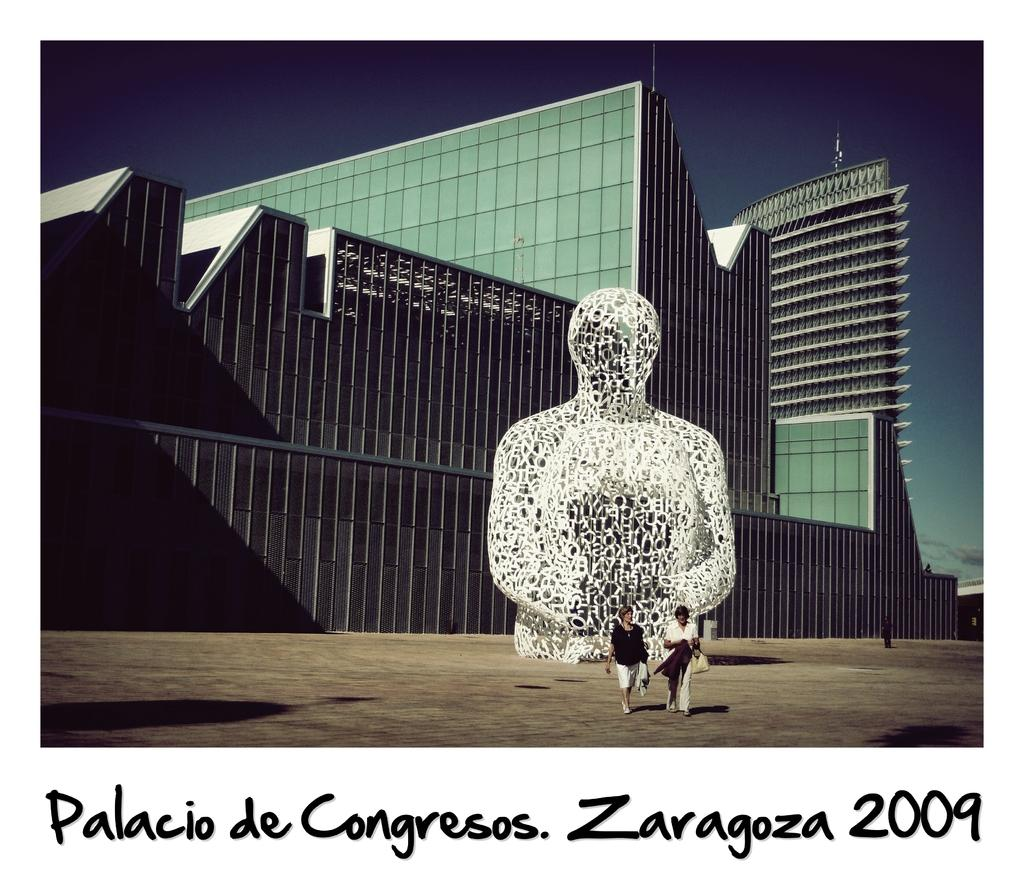<image>
Share a concise interpretation of the image provided. the palacio de congresos has a statue of a person sitting 